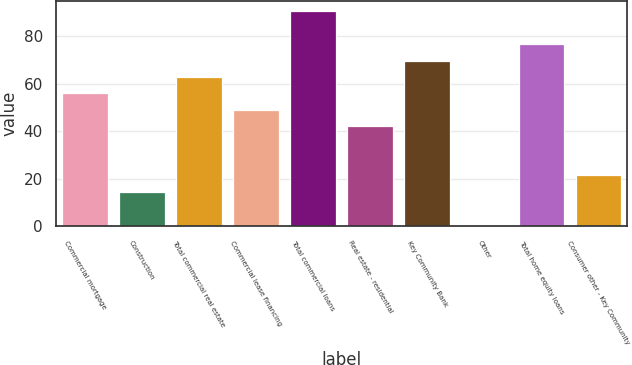Convert chart to OTSL. <chart><loc_0><loc_0><loc_500><loc_500><bar_chart><fcel>Commercial mortgage<fcel>Construction<fcel>Total commercial real estate<fcel>Commercial lease financing<fcel>Total commercial loans<fcel>Real estate - residential<fcel>Key Community Bank<fcel>Other<fcel>Total home equity loans<fcel>Consumer other - Key Community<nl><fcel>56<fcel>14.6<fcel>62.9<fcel>49.1<fcel>90.5<fcel>42.2<fcel>69.8<fcel>0.8<fcel>76.7<fcel>21.5<nl></chart> 